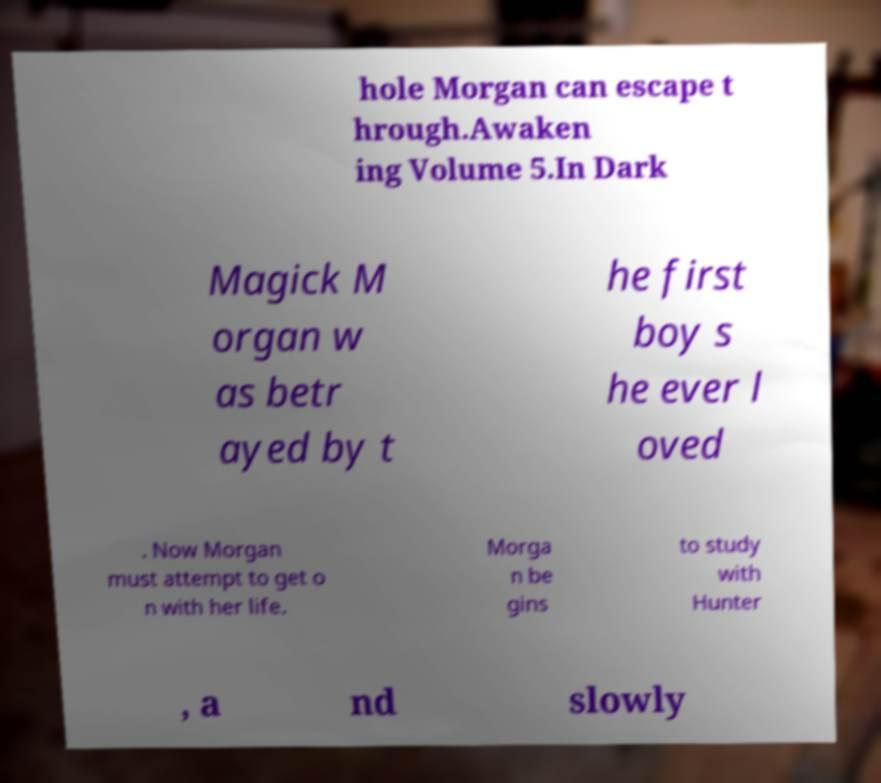Please read and relay the text visible in this image. What does it say? hole Morgan can escape t hrough.Awaken ing Volume 5.In Dark Magick M organ w as betr ayed by t he first boy s he ever l oved . Now Morgan must attempt to get o n with her life. Morga n be gins to study with Hunter , a nd slowly 